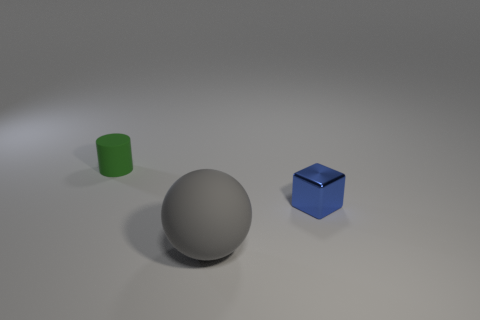Is the number of tiny cyan cylinders less than the number of rubber balls?
Ensure brevity in your answer.  Yes. There is a small green object behind the tiny object that is on the right side of the thing on the left side of the sphere; what is its material?
Provide a short and direct response. Rubber. What material is the green thing?
Provide a short and direct response. Rubber. There is a thing that is left of the matte ball; does it have the same color as the matte thing in front of the tiny blue block?
Provide a short and direct response. No. Are there more large cyan metal cylinders than tiny green cylinders?
Keep it short and to the point. No. What number of shiny cubes have the same color as the tiny rubber cylinder?
Make the answer very short. 0. The thing that is in front of the small green rubber thing and behind the rubber ball is made of what material?
Offer a very short reply. Metal. Is the small thing that is on the right side of the gray sphere made of the same material as the tiny thing that is behind the small shiny object?
Your answer should be very brief. No. The blue metal thing has what size?
Your response must be concise. Small. There is a green cylinder; how many rubber spheres are in front of it?
Keep it short and to the point. 1. 